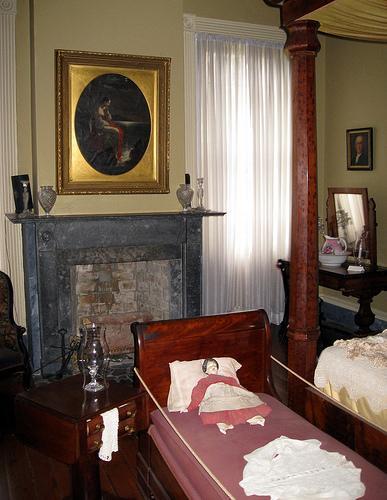How many dolls in the photo?
Give a very brief answer. 1. How many colors on the dolls dress?
Give a very brief answer. 2. 